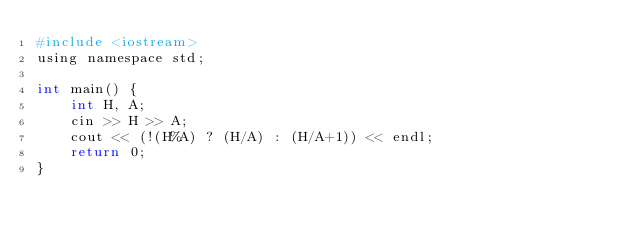Convert code to text. <code><loc_0><loc_0><loc_500><loc_500><_Python_>#include <iostream>
using namespace std;

int main() {
    int H, A;
    cin >> H >> A;
    cout << (!(H%A) ? (H/A) : (H/A+1)) << endl;
    return 0;
}
</code> 